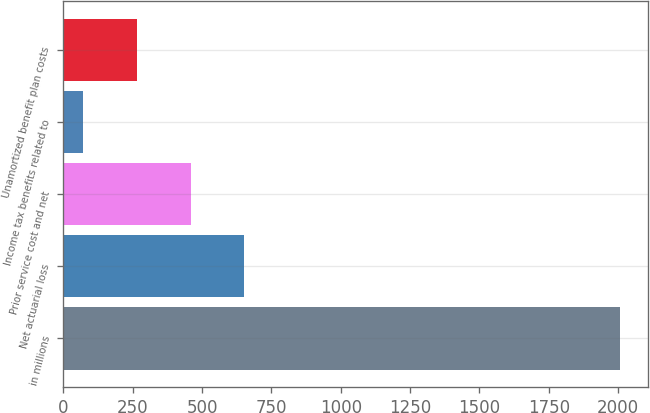<chart> <loc_0><loc_0><loc_500><loc_500><bar_chart><fcel>in millions<fcel>Net actuarial loss<fcel>Prior service cost and net<fcel>Income tax benefits related to<fcel>Unamortized benefit plan costs<nl><fcel>2008<fcel>652.8<fcel>459.2<fcel>72<fcel>265.6<nl></chart> 